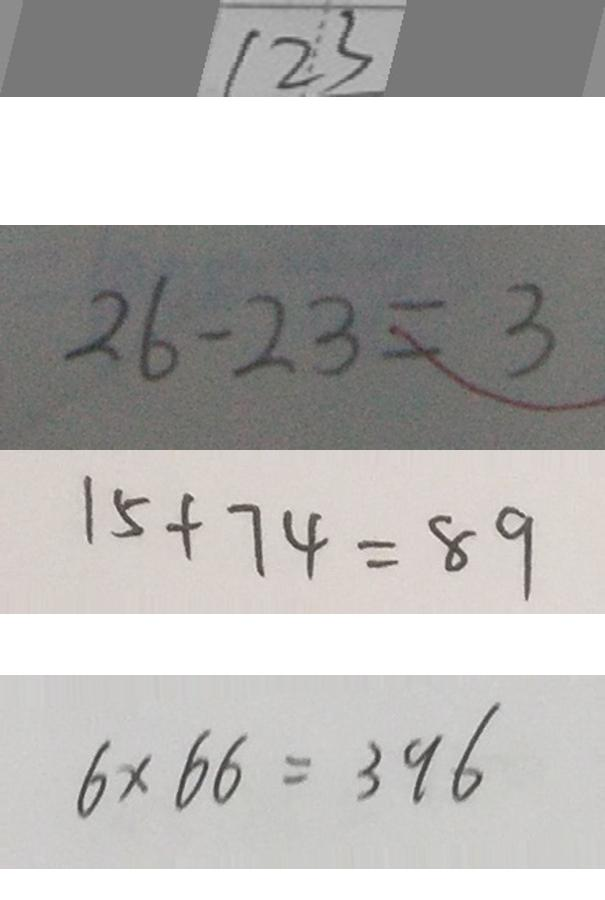Convert formula to latex. <formula><loc_0><loc_0><loc_500><loc_500>1 2 3 
 2 6 - 2 3 = 3 
 1 5 + 7 4 = 8 9 
 6 \times 6 6 = 3 9 6</formula> 